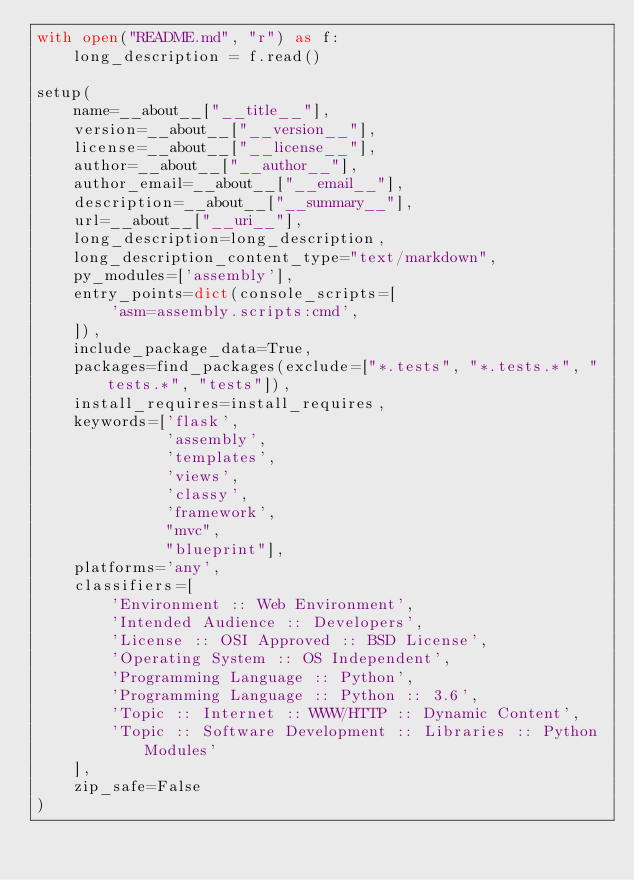<code> <loc_0><loc_0><loc_500><loc_500><_Python_>with open("README.md", "r") as f:
    long_description = f.read()

setup(
    name=__about__["__title__"],
    version=__about__["__version__"],
    license=__about__["__license__"],
    author=__about__["__author__"],
    author_email=__about__["__email__"],
    description=__about__["__summary__"],
    url=__about__["__uri__"],
    long_description=long_description,
    long_description_content_type="text/markdown",
    py_modules=['assembly'],
    entry_points=dict(console_scripts=[
        'asm=assembly.scripts:cmd',
    ]),
    include_package_data=True,
    packages=find_packages(exclude=["*.tests", "*.tests.*", "tests.*", "tests"]),
    install_requires=install_requires,
    keywords=['flask',
              'assembly',
              'templates',
              'views',
              'classy',
              'framework',
              "mvc",
              "blueprint"],
    platforms='any',
    classifiers=[
        'Environment :: Web Environment',
        'Intended Audience :: Developers',
        'License :: OSI Approved :: BSD License',
        'Operating System :: OS Independent',
        'Programming Language :: Python',
        'Programming Language :: Python :: 3.6',
        'Topic :: Internet :: WWW/HTTP :: Dynamic Content',
        'Topic :: Software Development :: Libraries :: Python Modules'
    ],
    zip_safe=False
)

</code> 